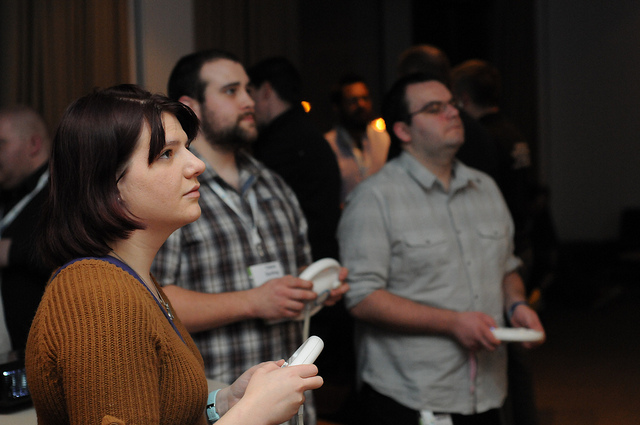<image>Which woman is wearing nail polish? I don't know which woman is wearing nail polish. There is no clear indication. Which woman is wearing nail polish? I am not sure which woman is wearing nail polish. None of the women in the image can be seen wearing nail polish. 